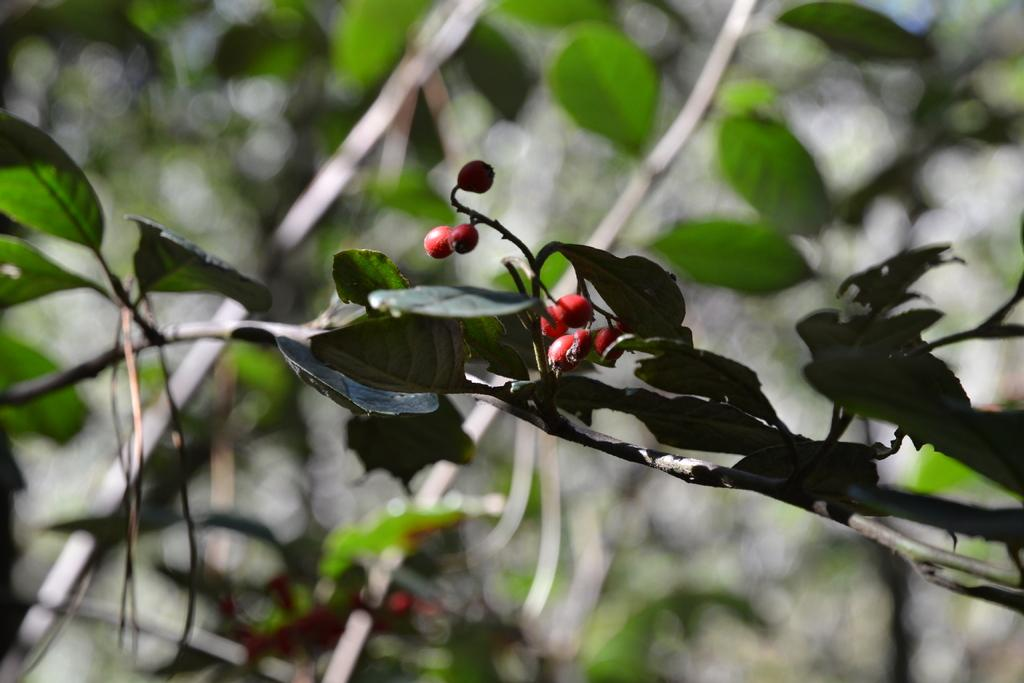What type of fruits are present in the image? There are small red fruits in the image. What else can be seen around the fruits? There are leaves around the fruits. What can be seen in the background of the image? There are plants visible in the background of the image. What type of brass instrument can be heard playing in the background of the image? There is no brass instrument or sound present in the image; it only features small red fruits, leaves, and plants in the background. 